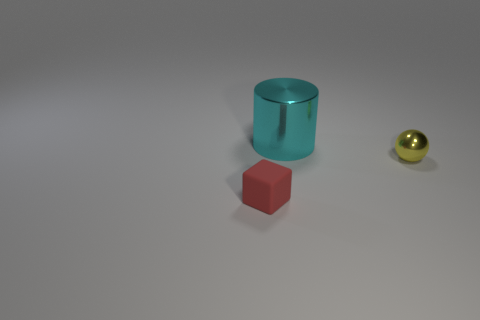Is the material of the cyan object the same as the yellow ball?
Your answer should be very brief. Yes. Is there another thing of the same shape as the cyan object?
Give a very brief answer. No. Do the small matte object left of the yellow object and the small metal object have the same color?
Keep it short and to the point. No. Does the object to the left of the big object have the same size as the metallic object to the left of the small yellow ball?
Your response must be concise. No. The ball that is made of the same material as the cyan cylinder is what size?
Provide a succinct answer. Small. What number of objects are in front of the yellow metal ball and behind the yellow ball?
Your answer should be very brief. 0. What number of things are large cyan objects or tiny things behind the red matte thing?
Your answer should be very brief. 2. The small object in front of the small yellow shiny thing is what color?
Provide a succinct answer. Red. What number of objects are either tiny objects that are to the left of the cyan metallic thing or shiny cylinders?
Offer a terse response. 2. There is a thing that is the same size as the red block; what is its color?
Your answer should be compact. Yellow. 